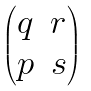Convert formula to latex. <formula><loc_0><loc_0><loc_500><loc_500>\begin{pmatrix} q & r \\ p & s \end{pmatrix}</formula> 